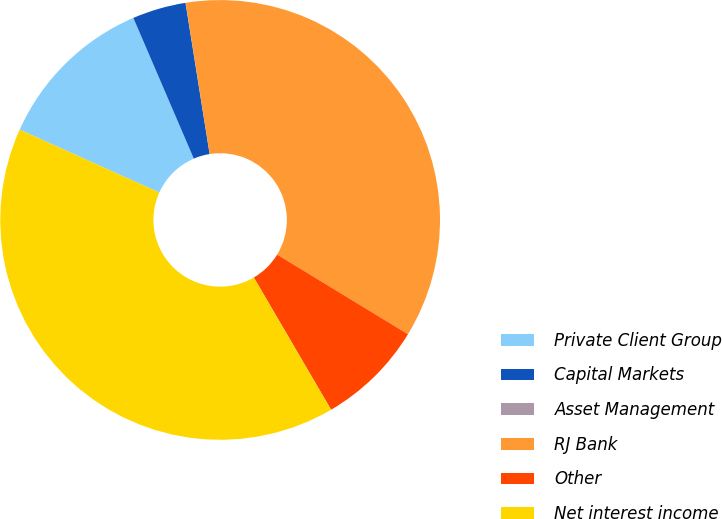Convert chart to OTSL. <chart><loc_0><loc_0><loc_500><loc_500><pie_chart><fcel>Private Client Group<fcel>Capital Markets<fcel>Asset Management<fcel>RJ Bank<fcel>Other<fcel>Net interest income<nl><fcel>11.81%<fcel>3.94%<fcel>0.01%<fcel>36.21%<fcel>7.88%<fcel>40.15%<nl></chart> 